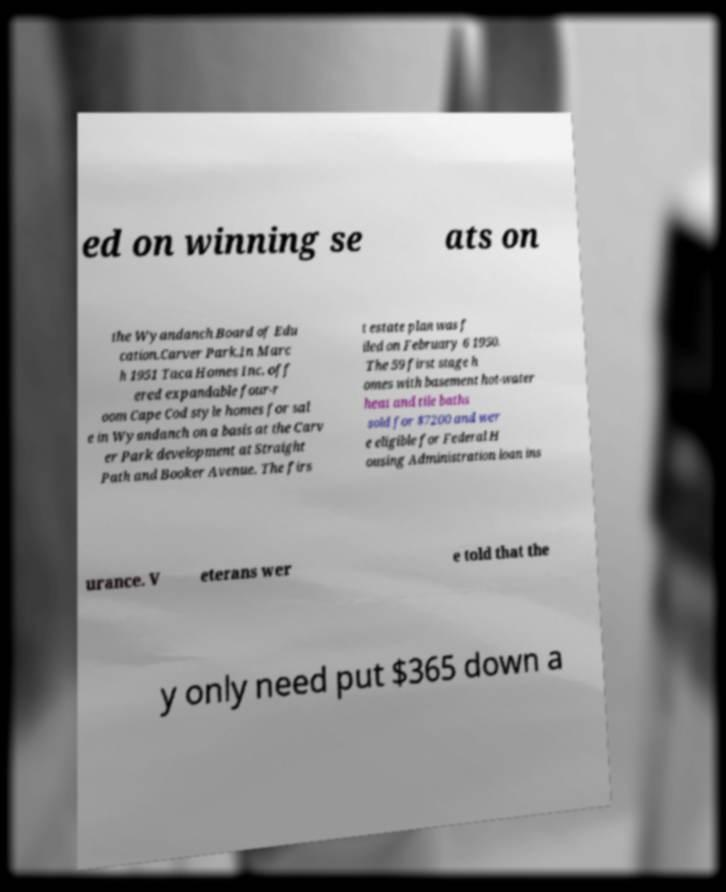Can you accurately transcribe the text from the provided image for me? ed on winning se ats on the Wyandanch Board of Edu cation.Carver Park.In Marc h 1951 Taca Homes Inc. off ered expandable four-r oom Cape Cod style homes for sal e in Wyandanch on a basis at the Carv er Park development at Straight Path and Booker Avenue. The firs t estate plan was f iled on February 6 1950. The 59 first stage h omes with basement hot-water heat and tile baths sold for $7200 and wer e eligible for Federal H ousing Administration loan ins urance. V eterans wer e told that the y only need put $365 down a 